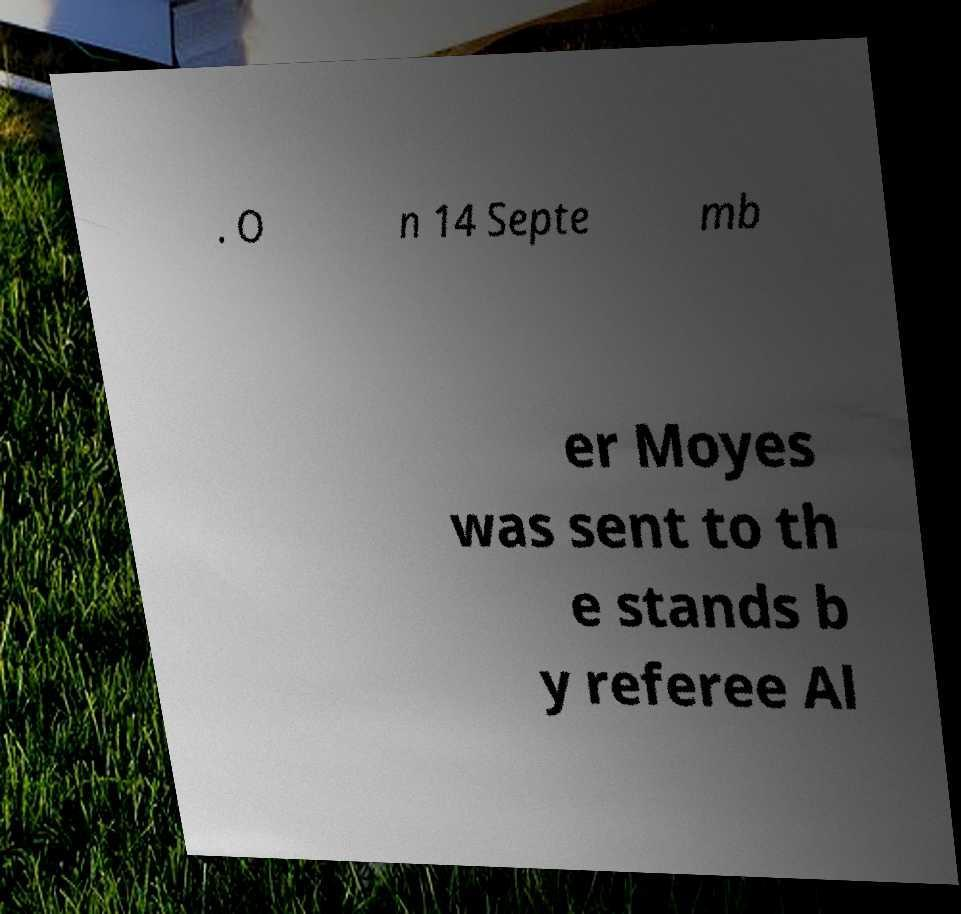Can you read and provide the text displayed in the image?This photo seems to have some interesting text. Can you extract and type it out for me? . O n 14 Septe mb er Moyes was sent to th e stands b y referee Al 